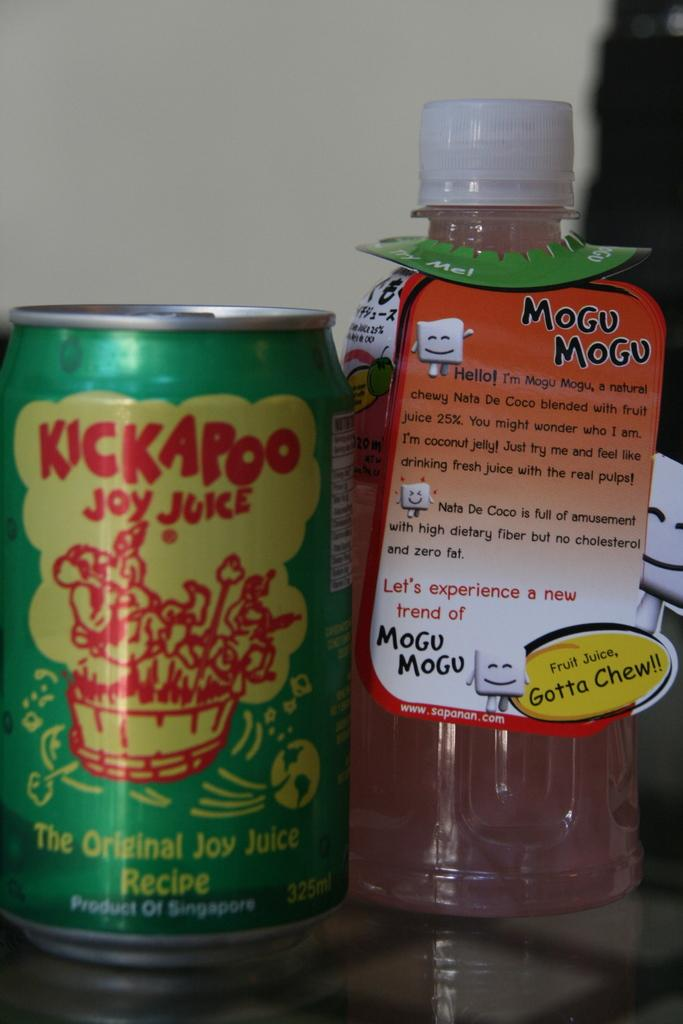What type of container is present in the image? There is a tin present in the image. What type of beverage is present in the image? There is a bottle of juice present in the image. Where are the tin and the bottle of juice located in the image? Both the tin and the bottle of juice are on a table. What type of mist can be seen surrounding the tin in the image? There is no mist present in the image; it is a clear image of a tin and a bottle of juice on a table. 